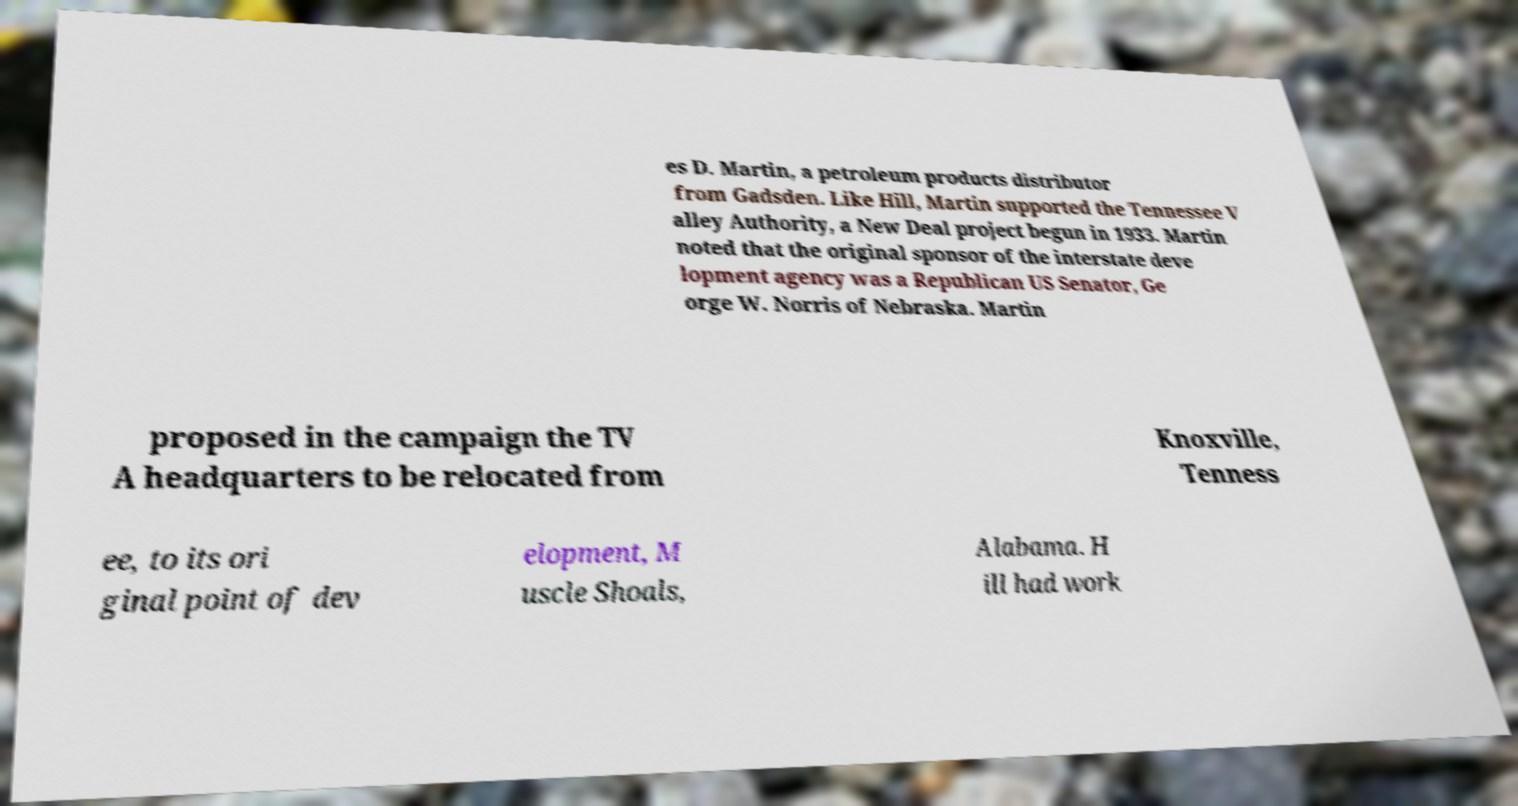I need the written content from this picture converted into text. Can you do that? es D. Martin, a petroleum products distributor from Gadsden. Like Hill, Martin supported the Tennessee V alley Authority, a New Deal project begun in 1933. Martin noted that the original sponsor of the interstate deve lopment agency was a Republican US Senator, Ge orge W. Norris of Nebraska. Martin proposed in the campaign the TV A headquarters to be relocated from Knoxville, Tenness ee, to its ori ginal point of dev elopment, M uscle Shoals, Alabama. H ill had work 